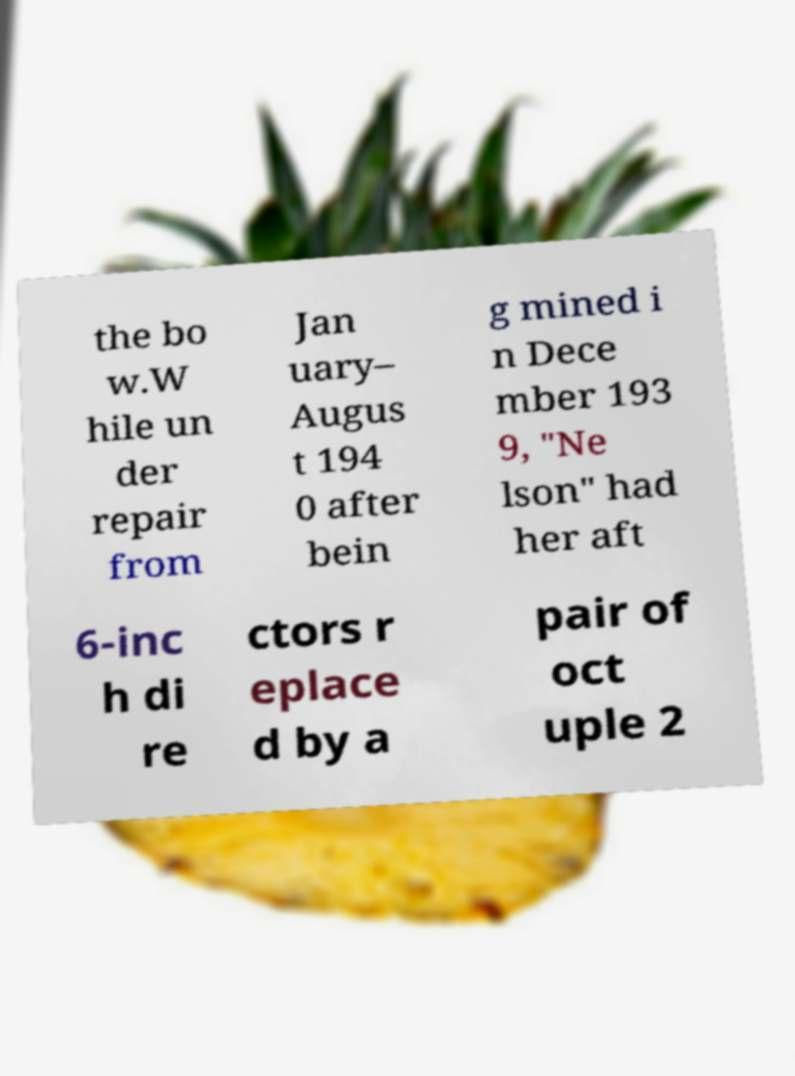There's text embedded in this image that I need extracted. Can you transcribe it verbatim? the bo w.W hile un der repair from Jan uary– Augus t 194 0 after bein g mined i n Dece mber 193 9, "Ne lson" had her aft 6-inc h di re ctors r eplace d by a pair of oct uple 2 